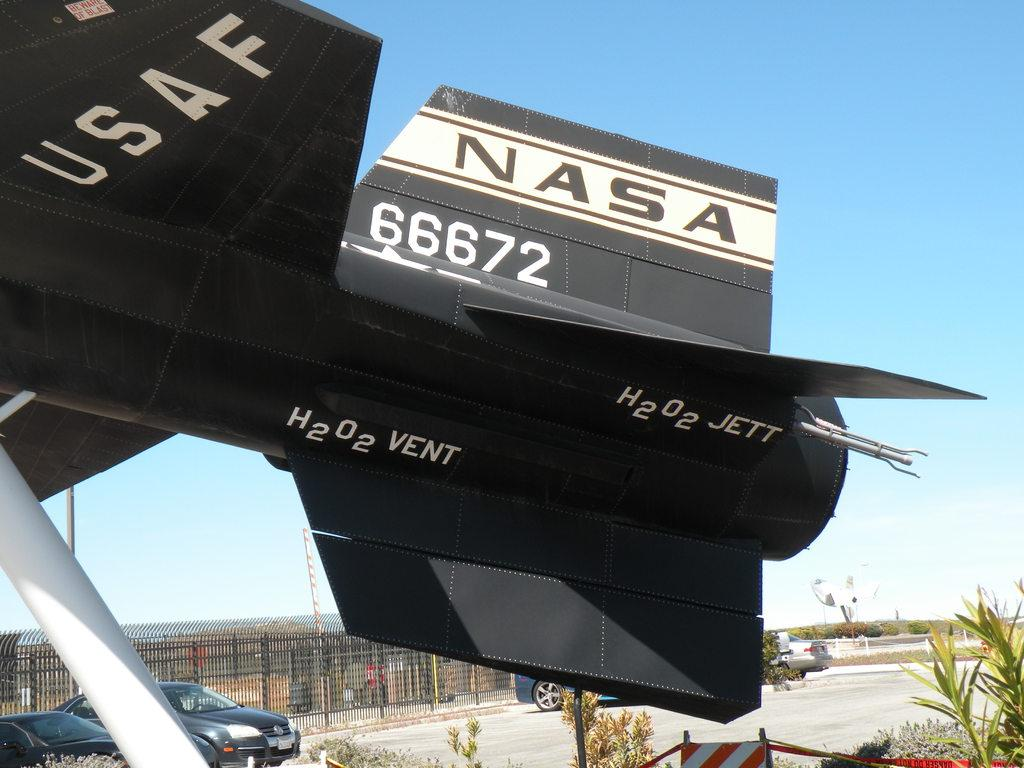<image>
Give a short and clear explanation of the subsequent image. The tail of a USAF NASA jet is seen near an empty parking lot 